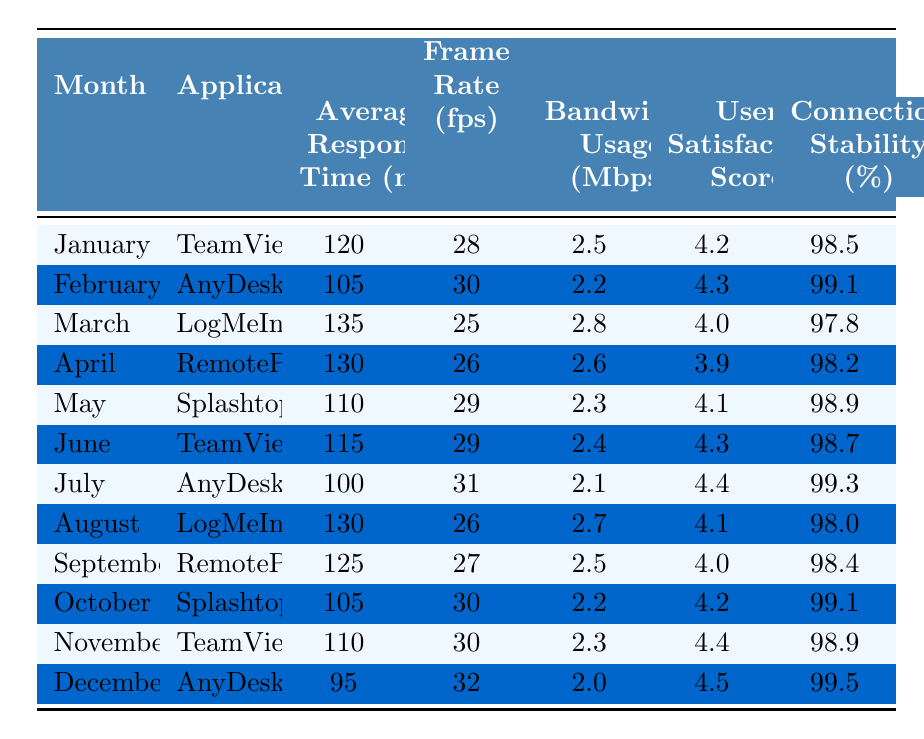What was the lowest average response time recorded across all applications? The lowest average response time in the data is found for AnyDesk in December, which is 95 ms. I looked through each application's monthly average response time and identified 95 ms as the minimum.
Answer: 95 ms Which application had the highest user satisfaction score in November? In November, TeamViewer achieved a user satisfaction score of 4.4, which is higher than any other score recorded that month.
Answer: TeamViewer What is the average frame rate for TeamViewer over the 12 months? TeamViewer's frame rates for January, June, and November are 28, 29, and 30 fps respectively. Calculating the average gives (28 + 29 + 30)/3 = 29 fps.
Answer: 29 fps Did AnyDesk have the highest bandwidth usage in any month? No, AnyDesk had a maximum bandwidth usage of 2.2 Mbps in February, which is lower than the maximum value of 2.8 Mbps recorded by LogMeIn in March.
Answer: No Which application consistently showed improved response times from January to December? AnyDesk had the most consistent improvement; its response time decreased from 105 ms in February to 95 ms in December, showing a downward trend over the months.
Answer: AnyDesk What is the average connection stability for Splashtop over the reporting period? The connection stability percentages for Splashtop in October and May are 99.1 and 98.9, respectively. The average is (99.1 + 98.9)/2 = 99.0%.
Answer: 99.0% Which month and application combination had the highest frame rate? AnyDesk recorded the highest frame rate of 32 fps in December, which is the peak value in the table.
Answer: December, AnyDesk What is the overall average bandwidth usage across all applications for the year? The total bandwidth usage for all months equals: 2.5 + 2.2 + 2.8 + 2.6 + 2.3 + 2.4 + 2.1 + 2.7 + 2.5 + 2.2 + 2.3 + 2.0 = 29.6 Mbps, which divided by 12 gives an average of 2.46667 Mbps (approximately 2.47 Mbps).
Answer: 2.47 Mbps Did LogMeIn have the best connection stability score overall in 2023? No, LogMeIn's highest connection stability score was 98.0% in August, which is not the highest overall; AnyDesk recorded 99.5% in December.
Answer: No Which application showed the most significant fluctuations in average response time? LogMeIn displayed the largest variation, with response times of 135 ms in March and dropping to 130 ms in August, indicating fluctuations month to month.
Answer: LogMeIn 